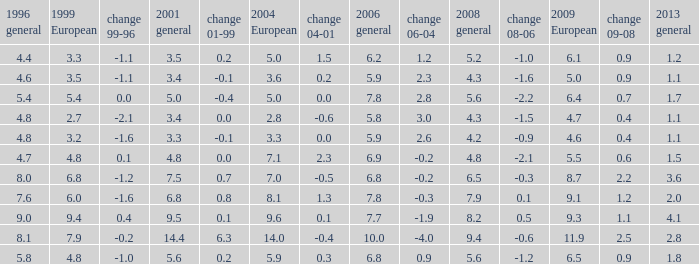What is the highest value for general 2008 when there is less than 5.5 in European 2009, more than 5.8 in general 2006, more than 3.3 in general 2001, and less than 3.6 for 2004 European? None. 